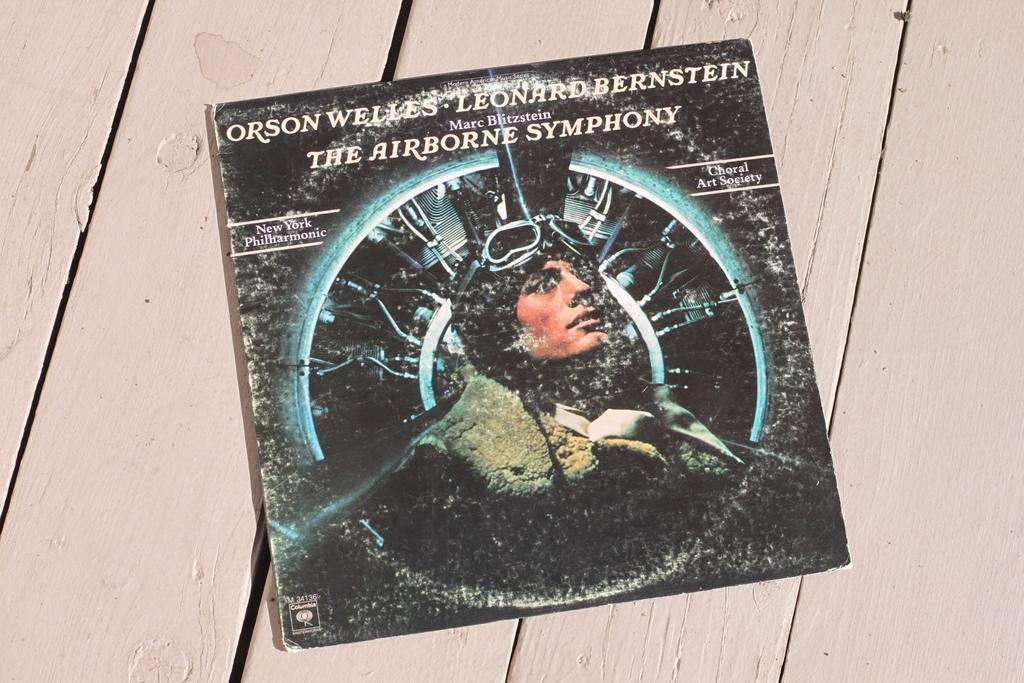Could you give a brief overview of what you see in this image? We can see board on the wooden surface,on this board we can see a person. 